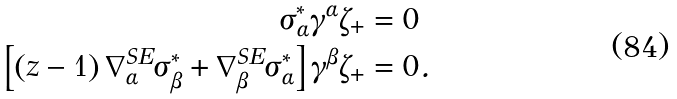<formula> <loc_0><loc_0><loc_500><loc_500>\sigma _ { \alpha } ^ { \ast } \gamma ^ { \alpha } \zeta _ { + } & = 0 \\ \left [ \left ( z - 1 \right ) \nabla ^ { S E } _ { \alpha } \sigma _ { \beta } ^ { \ast } + \nabla ^ { S E } _ { \beta } \sigma _ { \alpha } ^ { \ast } \right ] \gamma ^ { \beta } \zeta _ { + } & = 0 .</formula> 